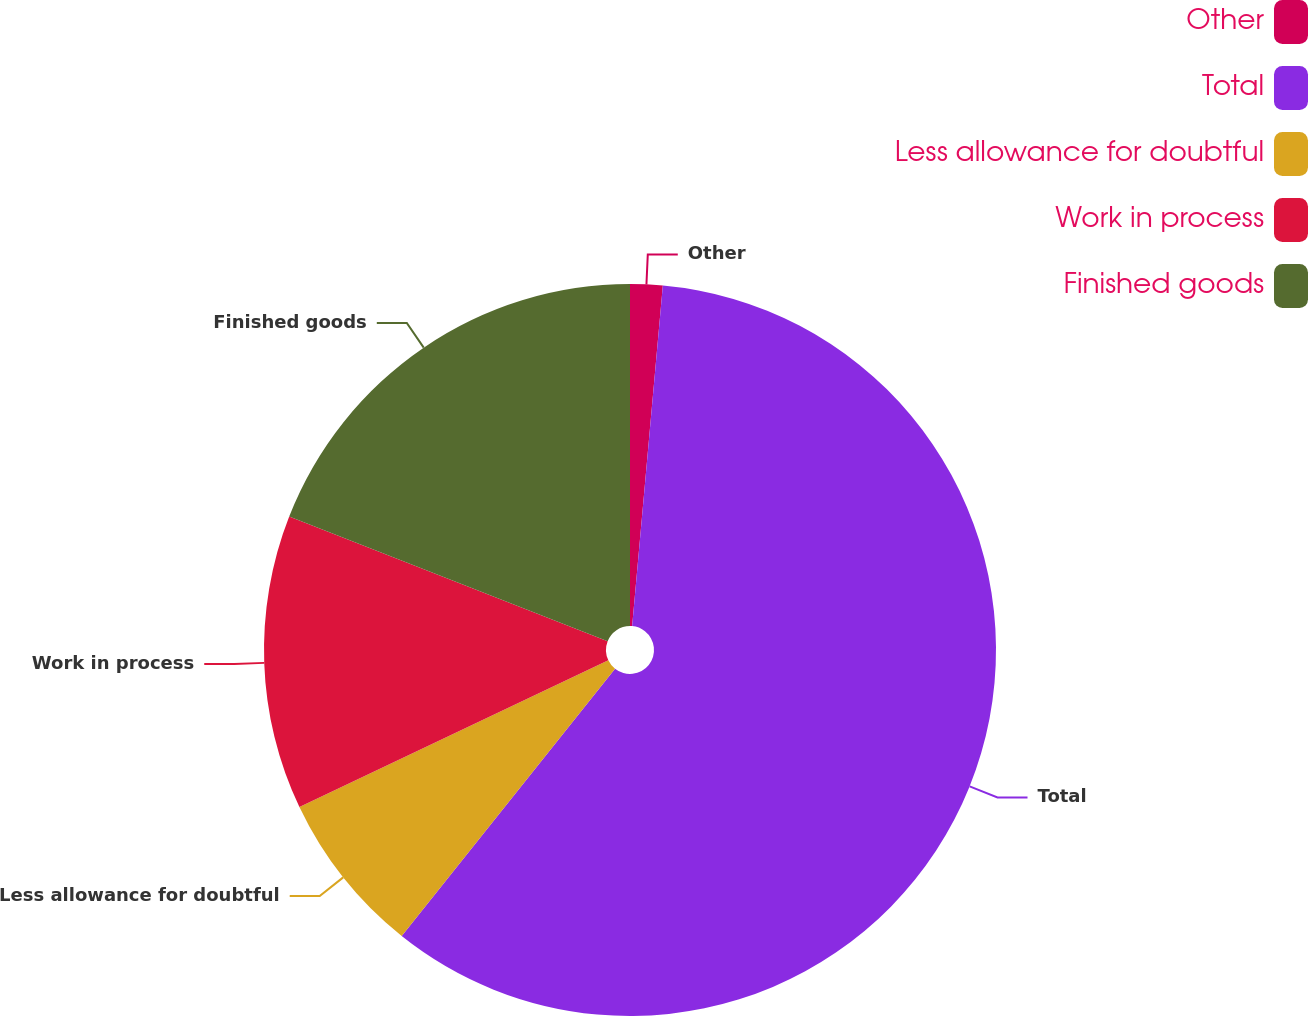Convert chart to OTSL. <chart><loc_0><loc_0><loc_500><loc_500><pie_chart><fcel>Other<fcel>Total<fcel>Less allowance for doubtful<fcel>Work in process<fcel>Finished goods<nl><fcel>1.43%<fcel>59.29%<fcel>7.22%<fcel>13.0%<fcel>19.06%<nl></chart> 